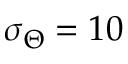Convert formula to latex. <formula><loc_0><loc_0><loc_500><loc_500>\sigma _ { \Theta } = 1 0</formula> 